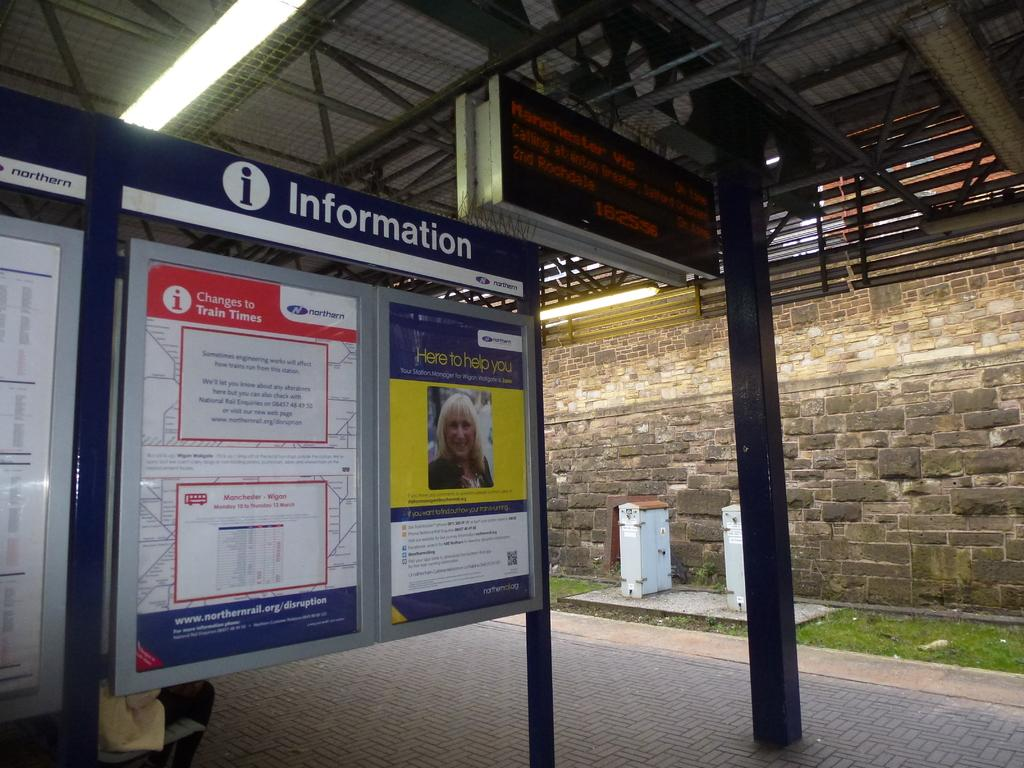<image>
Write a terse but informative summary of the picture. An information board at a train station with train times for today. 